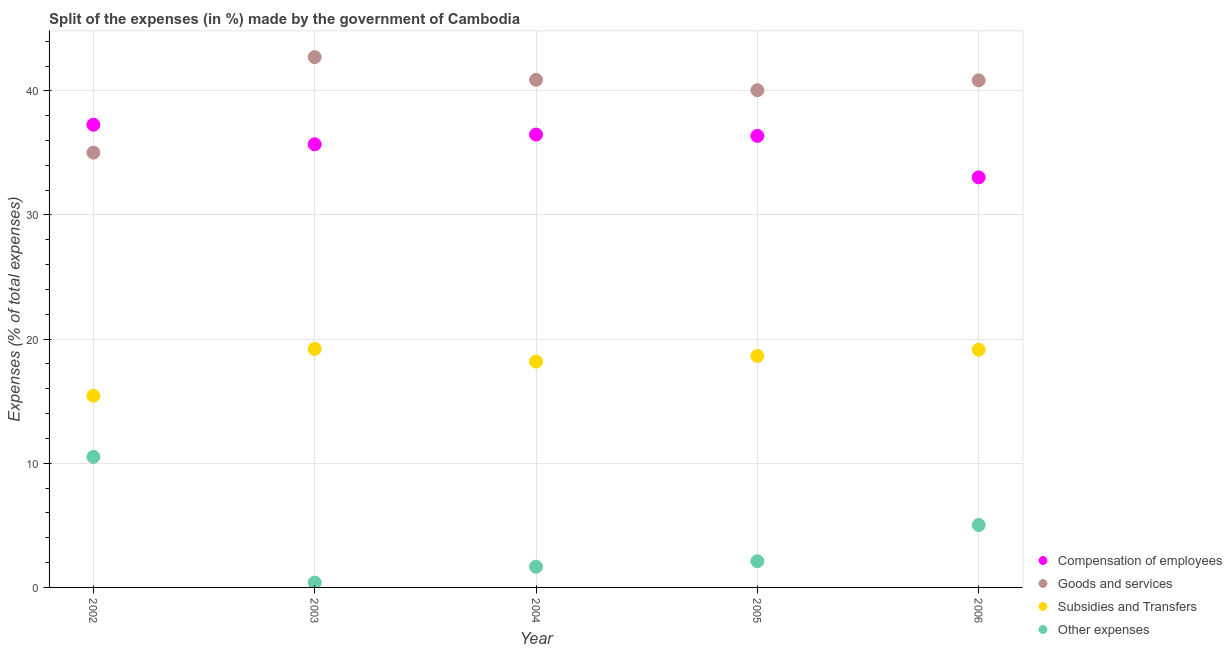Is the number of dotlines equal to the number of legend labels?
Give a very brief answer. Yes. What is the percentage of amount spent on goods and services in 2002?
Provide a short and direct response. 35.02. Across all years, what is the maximum percentage of amount spent on compensation of employees?
Ensure brevity in your answer.  37.27. Across all years, what is the minimum percentage of amount spent on goods and services?
Offer a very short reply. 35.02. What is the total percentage of amount spent on compensation of employees in the graph?
Your response must be concise. 178.84. What is the difference between the percentage of amount spent on other expenses in 2002 and that in 2004?
Provide a succinct answer. 8.85. What is the difference between the percentage of amount spent on compensation of employees in 2003 and the percentage of amount spent on subsidies in 2005?
Give a very brief answer. 17.05. What is the average percentage of amount spent on compensation of employees per year?
Provide a short and direct response. 35.77. In the year 2004, what is the difference between the percentage of amount spent on compensation of employees and percentage of amount spent on subsidies?
Ensure brevity in your answer.  18.29. In how many years, is the percentage of amount spent on other expenses greater than 20 %?
Provide a succinct answer. 0. What is the ratio of the percentage of amount spent on other expenses in 2004 to that in 2006?
Offer a terse response. 0.33. Is the percentage of amount spent on other expenses in 2002 less than that in 2004?
Provide a short and direct response. No. Is the difference between the percentage of amount spent on compensation of employees in 2002 and 2005 greater than the difference between the percentage of amount spent on subsidies in 2002 and 2005?
Provide a succinct answer. Yes. What is the difference between the highest and the second highest percentage of amount spent on other expenses?
Keep it short and to the point. 5.49. What is the difference between the highest and the lowest percentage of amount spent on compensation of employees?
Offer a terse response. 4.24. In how many years, is the percentage of amount spent on other expenses greater than the average percentage of amount spent on other expenses taken over all years?
Give a very brief answer. 2. Is it the case that in every year, the sum of the percentage of amount spent on compensation of employees and percentage of amount spent on subsidies is greater than the sum of percentage of amount spent on other expenses and percentage of amount spent on goods and services?
Your answer should be compact. Yes. Does the percentage of amount spent on subsidies monotonically increase over the years?
Your answer should be very brief. No. What is the difference between two consecutive major ticks on the Y-axis?
Your answer should be compact. 10. Are the values on the major ticks of Y-axis written in scientific E-notation?
Your answer should be compact. No. Does the graph contain grids?
Offer a terse response. Yes. Where does the legend appear in the graph?
Make the answer very short. Bottom right. What is the title of the graph?
Provide a short and direct response. Split of the expenses (in %) made by the government of Cambodia. Does "Australia" appear as one of the legend labels in the graph?
Ensure brevity in your answer.  No. What is the label or title of the Y-axis?
Your answer should be very brief. Expenses (% of total expenses). What is the Expenses (% of total expenses) in Compensation of employees in 2002?
Keep it short and to the point. 37.27. What is the Expenses (% of total expenses) in Goods and services in 2002?
Provide a succinct answer. 35.02. What is the Expenses (% of total expenses) of Subsidies and Transfers in 2002?
Your response must be concise. 15.44. What is the Expenses (% of total expenses) in Other expenses in 2002?
Offer a very short reply. 10.52. What is the Expenses (% of total expenses) in Compensation of employees in 2003?
Give a very brief answer. 35.7. What is the Expenses (% of total expenses) of Goods and services in 2003?
Ensure brevity in your answer.  42.72. What is the Expenses (% of total expenses) of Subsidies and Transfers in 2003?
Offer a terse response. 19.21. What is the Expenses (% of total expenses) of Other expenses in 2003?
Offer a very short reply. 0.39. What is the Expenses (% of total expenses) of Compensation of employees in 2004?
Keep it short and to the point. 36.48. What is the Expenses (% of total expenses) in Goods and services in 2004?
Your answer should be compact. 40.89. What is the Expenses (% of total expenses) of Subsidies and Transfers in 2004?
Make the answer very short. 18.19. What is the Expenses (% of total expenses) of Other expenses in 2004?
Keep it short and to the point. 1.67. What is the Expenses (% of total expenses) of Compensation of employees in 2005?
Keep it short and to the point. 36.37. What is the Expenses (% of total expenses) of Goods and services in 2005?
Offer a very short reply. 40.05. What is the Expenses (% of total expenses) in Subsidies and Transfers in 2005?
Ensure brevity in your answer.  18.64. What is the Expenses (% of total expenses) in Other expenses in 2005?
Provide a short and direct response. 2.11. What is the Expenses (% of total expenses) of Compensation of employees in 2006?
Offer a terse response. 33.03. What is the Expenses (% of total expenses) of Goods and services in 2006?
Offer a very short reply. 40.84. What is the Expenses (% of total expenses) of Subsidies and Transfers in 2006?
Your answer should be compact. 19.15. What is the Expenses (% of total expenses) in Other expenses in 2006?
Your response must be concise. 5.03. Across all years, what is the maximum Expenses (% of total expenses) in Compensation of employees?
Offer a very short reply. 37.27. Across all years, what is the maximum Expenses (% of total expenses) of Goods and services?
Provide a succinct answer. 42.72. Across all years, what is the maximum Expenses (% of total expenses) of Subsidies and Transfers?
Offer a terse response. 19.21. Across all years, what is the maximum Expenses (% of total expenses) in Other expenses?
Your answer should be compact. 10.52. Across all years, what is the minimum Expenses (% of total expenses) of Compensation of employees?
Your answer should be very brief. 33.03. Across all years, what is the minimum Expenses (% of total expenses) in Goods and services?
Offer a terse response. 35.02. Across all years, what is the minimum Expenses (% of total expenses) of Subsidies and Transfers?
Ensure brevity in your answer.  15.44. Across all years, what is the minimum Expenses (% of total expenses) of Other expenses?
Make the answer very short. 0.39. What is the total Expenses (% of total expenses) in Compensation of employees in the graph?
Keep it short and to the point. 178.84. What is the total Expenses (% of total expenses) of Goods and services in the graph?
Give a very brief answer. 199.52. What is the total Expenses (% of total expenses) in Subsidies and Transfers in the graph?
Provide a short and direct response. 90.64. What is the total Expenses (% of total expenses) of Other expenses in the graph?
Your answer should be very brief. 19.72. What is the difference between the Expenses (% of total expenses) in Compensation of employees in 2002 and that in 2003?
Offer a terse response. 1.57. What is the difference between the Expenses (% of total expenses) in Goods and services in 2002 and that in 2003?
Offer a very short reply. -7.7. What is the difference between the Expenses (% of total expenses) in Subsidies and Transfers in 2002 and that in 2003?
Your answer should be very brief. -3.78. What is the difference between the Expenses (% of total expenses) of Other expenses in 2002 and that in 2003?
Provide a short and direct response. 10.12. What is the difference between the Expenses (% of total expenses) in Compensation of employees in 2002 and that in 2004?
Your answer should be very brief. 0.79. What is the difference between the Expenses (% of total expenses) of Goods and services in 2002 and that in 2004?
Provide a succinct answer. -5.87. What is the difference between the Expenses (% of total expenses) of Subsidies and Transfers in 2002 and that in 2004?
Ensure brevity in your answer.  -2.75. What is the difference between the Expenses (% of total expenses) of Other expenses in 2002 and that in 2004?
Keep it short and to the point. 8.85. What is the difference between the Expenses (% of total expenses) in Compensation of employees in 2002 and that in 2005?
Your answer should be very brief. 0.9. What is the difference between the Expenses (% of total expenses) in Goods and services in 2002 and that in 2005?
Offer a terse response. -5.03. What is the difference between the Expenses (% of total expenses) of Subsidies and Transfers in 2002 and that in 2005?
Your answer should be very brief. -3.21. What is the difference between the Expenses (% of total expenses) of Other expenses in 2002 and that in 2005?
Offer a very short reply. 8.4. What is the difference between the Expenses (% of total expenses) of Compensation of employees in 2002 and that in 2006?
Provide a succinct answer. 4.24. What is the difference between the Expenses (% of total expenses) of Goods and services in 2002 and that in 2006?
Your response must be concise. -5.82. What is the difference between the Expenses (% of total expenses) in Subsidies and Transfers in 2002 and that in 2006?
Keep it short and to the point. -3.71. What is the difference between the Expenses (% of total expenses) in Other expenses in 2002 and that in 2006?
Your answer should be very brief. 5.49. What is the difference between the Expenses (% of total expenses) in Compensation of employees in 2003 and that in 2004?
Your answer should be very brief. -0.78. What is the difference between the Expenses (% of total expenses) of Goods and services in 2003 and that in 2004?
Offer a very short reply. 1.83. What is the difference between the Expenses (% of total expenses) in Subsidies and Transfers in 2003 and that in 2004?
Provide a short and direct response. 1.02. What is the difference between the Expenses (% of total expenses) of Other expenses in 2003 and that in 2004?
Ensure brevity in your answer.  -1.27. What is the difference between the Expenses (% of total expenses) in Compensation of employees in 2003 and that in 2005?
Give a very brief answer. -0.68. What is the difference between the Expenses (% of total expenses) in Goods and services in 2003 and that in 2005?
Keep it short and to the point. 2.67. What is the difference between the Expenses (% of total expenses) of Subsidies and Transfers in 2003 and that in 2005?
Give a very brief answer. 0.57. What is the difference between the Expenses (% of total expenses) of Other expenses in 2003 and that in 2005?
Give a very brief answer. -1.72. What is the difference between the Expenses (% of total expenses) of Compensation of employees in 2003 and that in 2006?
Give a very brief answer. 2.67. What is the difference between the Expenses (% of total expenses) of Goods and services in 2003 and that in 2006?
Give a very brief answer. 1.88. What is the difference between the Expenses (% of total expenses) of Subsidies and Transfers in 2003 and that in 2006?
Offer a very short reply. 0.07. What is the difference between the Expenses (% of total expenses) in Other expenses in 2003 and that in 2006?
Your answer should be very brief. -4.63. What is the difference between the Expenses (% of total expenses) in Compensation of employees in 2004 and that in 2005?
Give a very brief answer. 0.11. What is the difference between the Expenses (% of total expenses) of Goods and services in 2004 and that in 2005?
Provide a succinct answer. 0.84. What is the difference between the Expenses (% of total expenses) in Subsidies and Transfers in 2004 and that in 2005?
Your answer should be compact. -0.45. What is the difference between the Expenses (% of total expenses) of Other expenses in 2004 and that in 2005?
Your answer should be compact. -0.44. What is the difference between the Expenses (% of total expenses) of Compensation of employees in 2004 and that in 2006?
Your answer should be compact. 3.45. What is the difference between the Expenses (% of total expenses) in Goods and services in 2004 and that in 2006?
Give a very brief answer. 0.05. What is the difference between the Expenses (% of total expenses) of Subsidies and Transfers in 2004 and that in 2006?
Your answer should be very brief. -0.96. What is the difference between the Expenses (% of total expenses) of Other expenses in 2004 and that in 2006?
Offer a very short reply. -3.36. What is the difference between the Expenses (% of total expenses) in Compensation of employees in 2005 and that in 2006?
Provide a succinct answer. 3.34. What is the difference between the Expenses (% of total expenses) in Goods and services in 2005 and that in 2006?
Ensure brevity in your answer.  -0.79. What is the difference between the Expenses (% of total expenses) of Subsidies and Transfers in 2005 and that in 2006?
Make the answer very short. -0.5. What is the difference between the Expenses (% of total expenses) of Other expenses in 2005 and that in 2006?
Your answer should be very brief. -2.92. What is the difference between the Expenses (% of total expenses) in Compensation of employees in 2002 and the Expenses (% of total expenses) in Goods and services in 2003?
Your response must be concise. -5.45. What is the difference between the Expenses (% of total expenses) of Compensation of employees in 2002 and the Expenses (% of total expenses) of Subsidies and Transfers in 2003?
Your response must be concise. 18.06. What is the difference between the Expenses (% of total expenses) of Compensation of employees in 2002 and the Expenses (% of total expenses) of Other expenses in 2003?
Provide a short and direct response. 36.87. What is the difference between the Expenses (% of total expenses) in Goods and services in 2002 and the Expenses (% of total expenses) in Subsidies and Transfers in 2003?
Provide a short and direct response. 15.81. What is the difference between the Expenses (% of total expenses) in Goods and services in 2002 and the Expenses (% of total expenses) in Other expenses in 2003?
Make the answer very short. 34.63. What is the difference between the Expenses (% of total expenses) in Subsidies and Transfers in 2002 and the Expenses (% of total expenses) in Other expenses in 2003?
Provide a succinct answer. 15.04. What is the difference between the Expenses (% of total expenses) of Compensation of employees in 2002 and the Expenses (% of total expenses) of Goods and services in 2004?
Keep it short and to the point. -3.62. What is the difference between the Expenses (% of total expenses) in Compensation of employees in 2002 and the Expenses (% of total expenses) in Subsidies and Transfers in 2004?
Give a very brief answer. 19.08. What is the difference between the Expenses (% of total expenses) of Compensation of employees in 2002 and the Expenses (% of total expenses) of Other expenses in 2004?
Provide a short and direct response. 35.6. What is the difference between the Expenses (% of total expenses) in Goods and services in 2002 and the Expenses (% of total expenses) in Subsidies and Transfers in 2004?
Offer a very short reply. 16.83. What is the difference between the Expenses (% of total expenses) in Goods and services in 2002 and the Expenses (% of total expenses) in Other expenses in 2004?
Keep it short and to the point. 33.35. What is the difference between the Expenses (% of total expenses) of Subsidies and Transfers in 2002 and the Expenses (% of total expenses) of Other expenses in 2004?
Offer a terse response. 13.77. What is the difference between the Expenses (% of total expenses) in Compensation of employees in 2002 and the Expenses (% of total expenses) in Goods and services in 2005?
Your answer should be compact. -2.78. What is the difference between the Expenses (% of total expenses) of Compensation of employees in 2002 and the Expenses (% of total expenses) of Subsidies and Transfers in 2005?
Offer a terse response. 18.63. What is the difference between the Expenses (% of total expenses) of Compensation of employees in 2002 and the Expenses (% of total expenses) of Other expenses in 2005?
Make the answer very short. 35.16. What is the difference between the Expenses (% of total expenses) of Goods and services in 2002 and the Expenses (% of total expenses) of Subsidies and Transfers in 2005?
Provide a succinct answer. 16.38. What is the difference between the Expenses (% of total expenses) in Goods and services in 2002 and the Expenses (% of total expenses) in Other expenses in 2005?
Provide a succinct answer. 32.91. What is the difference between the Expenses (% of total expenses) in Subsidies and Transfers in 2002 and the Expenses (% of total expenses) in Other expenses in 2005?
Keep it short and to the point. 13.33. What is the difference between the Expenses (% of total expenses) in Compensation of employees in 2002 and the Expenses (% of total expenses) in Goods and services in 2006?
Keep it short and to the point. -3.57. What is the difference between the Expenses (% of total expenses) of Compensation of employees in 2002 and the Expenses (% of total expenses) of Subsidies and Transfers in 2006?
Make the answer very short. 18.12. What is the difference between the Expenses (% of total expenses) in Compensation of employees in 2002 and the Expenses (% of total expenses) in Other expenses in 2006?
Offer a terse response. 32.24. What is the difference between the Expenses (% of total expenses) of Goods and services in 2002 and the Expenses (% of total expenses) of Subsidies and Transfers in 2006?
Your answer should be compact. 15.87. What is the difference between the Expenses (% of total expenses) in Goods and services in 2002 and the Expenses (% of total expenses) in Other expenses in 2006?
Your response must be concise. 29.99. What is the difference between the Expenses (% of total expenses) of Subsidies and Transfers in 2002 and the Expenses (% of total expenses) of Other expenses in 2006?
Make the answer very short. 10.41. What is the difference between the Expenses (% of total expenses) in Compensation of employees in 2003 and the Expenses (% of total expenses) in Goods and services in 2004?
Make the answer very short. -5.19. What is the difference between the Expenses (% of total expenses) of Compensation of employees in 2003 and the Expenses (% of total expenses) of Subsidies and Transfers in 2004?
Offer a terse response. 17.5. What is the difference between the Expenses (% of total expenses) in Compensation of employees in 2003 and the Expenses (% of total expenses) in Other expenses in 2004?
Your response must be concise. 34.03. What is the difference between the Expenses (% of total expenses) in Goods and services in 2003 and the Expenses (% of total expenses) in Subsidies and Transfers in 2004?
Offer a terse response. 24.53. What is the difference between the Expenses (% of total expenses) in Goods and services in 2003 and the Expenses (% of total expenses) in Other expenses in 2004?
Offer a terse response. 41.05. What is the difference between the Expenses (% of total expenses) of Subsidies and Transfers in 2003 and the Expenses (% of total expenses) of Other expenses in 2004?
Your answer should be very brief. 17.54. What is the difference between the Expenses (% of total expenses) in Compensation of employees in 2003 and the Expenses (% of total expenses) in Goods and services in 2005?
Provide a short and direct response. -4.35. What is the difference between the Expenses (% of total expenses) of Compensation of employees in 2003 and the Expenses (% of total expenses) of Subsidies and Transfers in 2005?
Your response must be concise. 17.05. What is the difference between the Expenses (% of total expenses) of Compensation of employees in 2003 and the Expenses (% of total expenses) of Other expenses in 2005?
Your answer should be very brief. 33.58. What is the difference between the Expenses (% of total expenses) of Goods and services in 2003 and the Expenses (% of total expenses) of Subsidies and Transfers in 2005?
Provide a succinct answer. 24.07. What is the difference between the Expenses (% of total expenses) of Goods and services in 2003 and the Expenses (% of total expenses) of Other expenses in 2005?
Provide a short and direct response. 40.61. What is the difference between the Expenses (% of total expenses) of Subsidies and Transfers in 2003 and the Expenses (% of total expenses) of Other expenses in 2005?
Keep it short and to the point. 17.1. What is the difference between the Expenses (% of total expenses) of Compensation of employees in 2003 and the Expenses (% of total expenses) of Goods and services in 2006?
Provide a short and direct response. -5.15. What is the difference between the Expenses (% of total expenses) of Compensation of employees in 2003 and the Expenses (% of total expenses) of Subsidies and Transfers in 2006?
Provide a succinct answer. 16.55. What is the difference between the Expenses (% of total expenses) in Compensation of employees in 2003 and the Expenses (% of total expenses) in Other expenses in 2006?
Your answer should be compact. 30.67. What is the difference between the Expenses (% of total expenses) of Goods and services in 2003 and the Expenses (% of total expenses) of Subsidies and Transfers in 2006?
Ensure brevity in your answer.  23.57. What is the difference between the Expenses (% of total expenses) in Goods and services in 2003 and the Expenses (% of total expenses) in Other expenses in 2006?
Your answer should be compact. 37.69. What is the difference between the Expenses (% of total expenses) of Subsidies and Transfers in 2003 and the Expenses (% of total expenses) of Other expenses in 2006?
Give a very brief answer. 14.19. What is the difference between the Expenses (% of total expenses) in Compensation of employees in 2004 and the Expenses (% of total expenses) in Goods and services in 2005?
Your answer should be compact. -3.57. What is the difference between the Expenses (% of total expenses) of Compensation of employees in 2004 and the Expenses (% of total expenses) of Subsidies and Transfers in 2005?
Provide a succinct answer. 17.83. What is the difference between the Expenses (% of total expenses) of Compensation of employees in 2004 and the Expenses (% of total expenses) of Other expenses in 2005?
Your answer should be compact. 34.37. What is the difference between the Expenses (% of total expenses) in Goods and services in 2004 and the Expenses (% of total expenses) in Subsidies and Transfers in 2005?
Give a very brief answer. 22.25. What is the difference between the Expenses (% of total expenses) in Goods and services in 2004 and the Expenses (% of total expenses) in Other expenses in 2005?
Provide a succinct answer. 38.78. What is the difference between the Expenses (% of total expenses) in Subsidies and Transfers in 2004 and the Expenses (% of total expenses) in Other expenses in 2005?
Your response must be concise. 16.08. What is the difference between the Expenses (% of total expenses) in Compensation of employees in 2004 and the Expenses (% of total expenses) in Goods and services in 2006?
Make the answer very short. -4.36. What is the difference between the Expenses (% of total expenses) of Compensation of employees in 2004 and the Expenses (% of total expenses) of Subsidies and Transfers in 2006?
Offer a terse response. 17.33. What is the difference between the Expenses (% of total expenses) of Compensation of employees in 2004 and the Expenses (% of total expenses) of Other expenses in 2006?
Give a very brief answer. 31.45. What is the difference between the Expenses (% of total expenses) in Goods and services in 2004 and the Expenses (% of total expenses) in Subsidies and Transfers in 2006?
Keep it short and to the point. 21.74. What is the difference between the Expenses (% of total expenses) of Goods and services in 2004 and the Expenses (% of total expenses) of Other expenses in 2006?
Your answer should be compact. 35.86. What is the difference between the Expenses (% of total expenses) of Subsidies and Transfers in 2004 and the Expenses (% of total expenses) of Other expenses in 2006?
Provide a short and direct response. 13.16. What is the difference between the Expenses (% of total expenses) in Compensation of employees in 2005 and the Expenses (% of total expenses) in Goods and services in 2006?
Offer a terse response. -4.47. What is the difference between the Expenses (% of total expenses) of Compensation of employees in 2005 and the Expenses (% of total expenses) of Subsidies and Transfers in 2006?
Ensure brevity in your answer.  17.22. What is the difference between the Expenses (% of total expenses) of Compensation of employees in 2005 and the Expenses (% of total expenses) of Other expenses in 2006?
Give a very brief answer. 31.34. What is the difference between the Expenses (% of total expenses) of Goods and services in 2005 and the Expenses (% of total expenses) of Subsidies and Transfers in 2006?
Your answer should be very brief. 20.9. What is the difference between the Expenses (% of total expenses) in Goods and services in 2005 and the Expenses (% of total expenses) in Other expenses in 2006?
Give a very brief answer. 35.02. What is the difference between the Expenses (% of total expenses) of Subsidies and Transfers in 2005 and the Expenses (% of total expenses) of Other expenses in 2006?
Ensure brevity in your answer.  13.62. What is the average Expenses (% of total expenses) in Compensation of employees per year?
Your answer should be very brief. 35.77. What is the average Expenses (% of total expenses) of Goods and services per year?
Offer a terse response. 39.9. What is the average Expenses (% of total expenses) of Subsidies and Transfers per year?
Provide a short and direct response. 18.13. What is the average Expenses (% of total expenses) of Other expenses per year?
Your answer should be compact. 3.94. In the year 2002, what is the difference between the Expenses (% of total expenses) of Compensation of employees and Expenses (% of total expenses) of Goods and services?
Your answer should be very brief. 2.25. In the year 2002, what is the difference between the Expenses (% of total expenses) of Compensation of employees and Expenses (% of total expenses) of Subsidies and Transfers?
Your answer should be very brief. 21.83. In the year 2002, what is the difference between the Expenses (% of total expenses) in Compensation of employees and Expenses (% of total expenses) in Other expenses?
Provide a succinct answer. 26.75. In the year 2002, what is the difference between the Expenses (% of total expenses) of Goods and services and Expenses (% of total expenses) of Subsidies and Transfers?
Keep it short and to the point. 19.58. In the year 2002, what is the difference between the Expenses (% of total expenses) in Goods and services and Expenses (% of total expenses) in Other expenses?
Give a very brief answer. 24.51. In the year 2002, what is the difference between the Expenses (% of total expenses) of Subsidies and Transfers and Expenses (% of total expenses) of Other expenses?
Your answer should be very brief. 4.92. In the year 2003, what is the difference between the Expenses (% of total expenses) in Compensation of employees and Expenses (% of total expenses) in Goods and services?
Provide a succinct answer. -7.02. In the year 2003, what is the difference between the Expenses (% of total expenses) in Compensation of employees and Expenses (% of total expenses) in Subsidies and Transfers?
Your answer should be very brief. 16.48. In the year 2003, what is the difference between the Expenses (% of total expenses) of Compensation of employees and Expenses (% of total expenses) of Other expenses?
Offer a very short reply. 35.3. In the year 2003, what is the difference between the Expenses (% of total expenses) in Goods and services and Expenses (% of total expenses) in Subsidies and Transfers?
Provide a succinct answer. 23.5. In the year 2003, what is the difference between the Expenses (% of total expenses) in Goods and services and Expenses (% of total expenses) in Other expenses?
Provide a short and direct response. 42.32. In the year 2003, what is the difference between the Expenses (% of total expenses) in Subsidies and Transfers and Expenses (% of total expenses) in Other expenses?
Make the answer very short. 18.82. In the year 2004, what is the difference between the Expenses (% of total expenses) of Compensation of employees and Expenses (% of total expenses) of Goods and services?
Give a very brief answer. -4.41. In the year 2004, what is the difference between the Expenses (% of total expenses) in Compensation of employees and Expenses (% of total expenses) in Subsidies and Transfers?
Ensure brevity in your answer.  18.29. In the year 2004, what is the difference between the Expenses (% of total expenses) in Compensation of employees and Expenses (% of total expenses) in Other expenses?
Offer a terse response. 34.81. In the year 2004, what is the difference between the Expenses (% of total expenses) in Goods and services and Expenses (% of total expenses) in Subsidies and Transfers?
Offer a very short reply. 22.7. In the year 2004, what is the difference between the Expenses (% of total expenses) of Goods and services and Expenses (% of total expenses) of Other expenses?
Keep it short and to the point. 39.22. In the year 2004, what is the difference between the Expenses (% of total expenses) in Subsidies and Transfers and Expenses (% of total expenses) in Other expenses?
Your answer should be compact. 16.52. In the year 2005, what is the difference between the Expenses (% of total expenses) in Compensation of employees and Expenses (% of total expenses) in Goods and services?
Make the answer very short. -3.68. In the year 2005, what is the difference between the Expenses (% of total expenses) in Compensation of employees and Expenses (% of total expenses) in Subsidies and Transfers?
Your answer should be compact. 17.73. In the year 2005, what is the difference between the Expenses (% of total expenses) in Compensation of employees and Expenses (% of total expenses) in Other expenses?
Ensure brevity in your answer.  34.26. In the year 2005, what is the difference between the Expenses (% of total expenses) of Goods and services and Expenses (% of total expenses) of Subsidies and Transfers?
Offer a terse response. 21.4. In the year 2005, what is the difference between the Expenses (% of total expenses) of Goods and services and Expenses (% of total expenses) of Other expenses?
Offer a very short reply. 37.94. In the year 2005, what is the difference between the Expenses (% of total expenses) in Subsidies and Transfers and Expenses (% of total expenses) in Other expenses?
Offer a terse response. 16.53. In the year 2006, what is the difference between the Expenses (% of total expenses) of Compensation of employees and Expenses (% of total expenses) of Goods and services?
Your response must be concise. -7.81. In the year 2006, what is the difference between the Expenses (% of total expenses) of Compensation of employees and Expenses (% of total expenses) of Subsidies and Transfers?
Your answer should be compact. 13.88. In the year 2006, what is the difference between the Expenses (% of total expenses) of Compensation of employees and Expenses (% of total expenses) of Other expenses?
Your answer should be compact. 28. In the year 2006, what is the difference between the Expenses (% of total expenses) of Goods and services and Expenses (% of total expenses) of Subsidies and Transfers?
Offer a very short reply. 21.69. In the year 2006, what is the difference between the Expenses (% of total expenses) in Goods and services and Expenses (% of total expenses) in Other expenses?
Provide a short and direct response. 35.81. In the year 2006, what is the difference between the Expenses (% of total expenses) in Subsidies and Transfers and Expenses (% of total expenses) in Other expenses?
Provide a short and direct response. 14.12. What is the ratio of the Expenses (% of total expenses) of Compensation of employees in 2002 to that in 2003?
Ensure brevity in your answer.  1.04. What is the ratio of the Expenses (% of total expenses) of Goods and services in 2002 to that in 2003?
Offer a very short reply. 0.82. What is the ratio of the Expenses (% of total expenses) of Subsidies and Transfers in 2002 to that in 2003?
Ensure brevity in your answer.  0.8. What is the ratio of the Expenses (% of total expenses) of Other expenses in 2002 to that in 2003?
Your response must be concise. 26.64. What is the ratio of the Expenses (% of total expenses) of Compensation of employees in 2002 to that in 2004?
Your answer should be compact. 1.02. What is the ratio of the Expenses (% of total expenses) of Goods and services in 2002 to that in 2004?
Your answer should be compact. 0.86. What is the ratio of the Expenses (% of total expenses) in Subsidies and Transfers in 2002 to that in 2004?
Your response must be concise. 0.85. What is the ratio of the Expenses (% of total expenses) of Other expenses in 2002 to that in 2004?
Your answer should be very brief. 6.3. What is the ratio of the Expenses (% of total expenses) in Compensation of employees in 2002 to that in 2005?
Your response must be concise. 1.02. What is the ratio of the Expenses (% of total expenses) in Goods and services in 2002 to that in 2005?
Make the answer very short. 0.87. What is the ratio of the Expenses (% of total expenses) of Subsidies and Transfers in 2002 to that in 2005?
Offer a terse response. 0.83. What is the ratio of the Expenses (% of total expenses) in Other expenses in 2002 to that in 2005?
Provide a succinct answer. 4.98. What is the ratio of the Expenses (% of total expenses) in Compensation of employees in 2002 to that in 2006?
Ensure brevity in your answer.  1.13. What is the ratio of the Expenses (% of total expenses) in Goods and services in 2002 to that in 2006?
Provide a succinct answer. 0.86. What is the ratio of the Expenses (% of total expenses) in Subsidies and Transfers in 2002 to that in 2006?
Keep it short and to the point. 0.81. What is the ratio of the Expenses (% of total expenses) in Other expenses in 2002 to that in 2006?
Provide a succinct answer. 2.09. What is the ratio of the Expenses (% of total expenses) in Compensation of employees in 2003 to that in 2004?
Offer a very short reply. 0.98. What is the ratio of the Expenses (% of total expenses) of Goods and services in 2003 to that in 2004?
Provide a short and direct response. 1.04. What is the ratio of the Expenses (% of total expenses) of Subsidies and Transfers in 2003 to that in 2004?
Provide a short and direct response. 1.06. What is the ratio of the Expenses (% of total expenses) in Other expenses in 2003 to that in 2004?
Provide a succinct answer. 0.24. What is the ratio of the Expenses (% of total expenses) in Compensation of employees in 2003 to that in 2005?
Your answer should be very brief. 0.98. What is the ratio of the Expenses (% of total expenses) in Goods and services in 2003 to that in 2005?
Make the answer very short. 1.07. What is the ratio of the Expenses (% of total expenses) of Subsidies and Transfers in 2003 to that in 2005?
Your answer should be compact. 1.03. What is the ratio of the Expenses (% of total expenses) in Other expenses in 2003 to that in 2005?
Offer a terse response. 0.19. What is the ratio of the Expenses (% of total expenses) of Compensation of employees in 2003 to that in 2006?
Ensure brevity in your answer.  1.08. What is the ratio of the Expenses (% of total expenses) in Goods and services in 2003 to that in 2006?
Provide a short and direct response. 1.05. What is the ratio of the Expenses (% of total expenses) in Subsidies and Transfers in 2003 to that in 2006?
Keep it short and to the point. 1. What is the ratio of the Expenses (% of total expenses) of Other expenses in 2003 to that in 2006?
Your answer should be very brief. 0.08. What is the ratio of the Expenses (% of total expenses) of Goods and services in 2004 to that in 2005?
Your answer should be very brief. 1.02. What is the ratio of the Expenses (% of total expenses) of Subsidies and Transfers in 2004 to that in 2005?
Your answer should be compact. 0.98. What is the ratio of the Expenses (% of total expenses) in Other expenses in 2004 to that in 2005?
Your response must be concise. 0.79. What is the ratio of the Expenses (% of total expenses) of Compensation of employees in 2004 to that in 2006?
Your answer should be very brief. 1.1. What is the ratio of the Expenses (% of total expenses) of Goods and services in 2004 to that in 2006?
Offer a very short reply. 1. What is the ratio of the Expenses (% of total expenses) of Other expenses in 2004 to that in 2006?
Provide a short and direct response. 0.33. What is the ratio of the Expenses (% of total expenses) of Compensation of employees in 2005 to that in 2006?
Make the answer very short. 1.1. What is the ratio of the Expenses (% of total expenses) of Goods and services in 2005 to that in 2006?
Your answer should be very brief. 0.98. What is the ratio of the Expenses (% of total expenses) of Subsidies and Transfers in 2005 to that in 2006?
Your response must be concise. 0.97. What is the ratio of the Expenses (% of total expenses) of Other expenses in 2005 to that in 2006?
Your response must be concise. 0.42. What is the difference between the highest and the second highest Expenses (% of total expenses) of Compensation of employees?
Keep it short and to the point. 0.79. What is the difference between the highest and the second highest Expenses (% of total expenses) in Goods and services?
Keep it short and to the point. 1.83. What is the difference between the highest and the second highest Expenses (% of total expenses) in Subsidies and Transfers?
Offer a very short reply. 0.07. What is the difference between the highest and the second highest Expenses (% of total expenses) of Other expenses?
Provide a succinct answer. 5.49. What is the difference between the highest and the lowest Expenses (% of total expenses) of Compensation of employees?
Offer a very short reply. 4.24. What is the difference between the highest and the lowest Expenses (% of total expenses) in Goods and services?
Provide a succinct answer. 7.7. What is the difference between the highest and the lowest Expenses (% of total expenses) of Subsidies and Transfers?
Your response must be concise. 3.78. What is the difference between the highest and the lowest Expenses (% of total expenses) in Other expenses?
Provide a short and direct response. 10.12. 